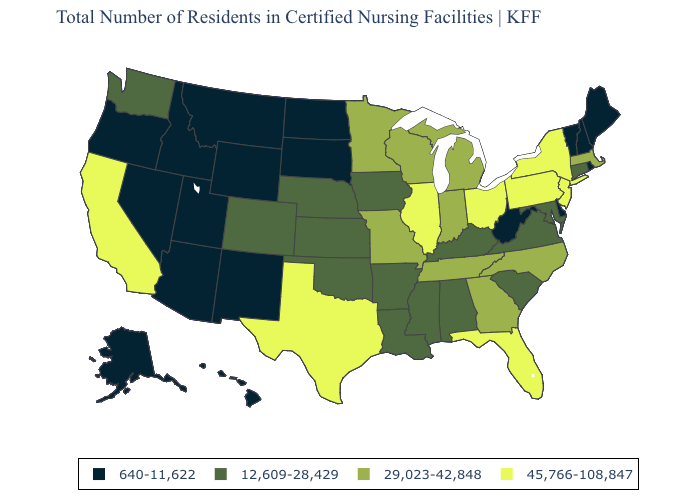What is the value of Montana?
Give a very brief answer. 640-11,622. Which states have the lowest value in the USA?
Quick response, please. Alaska, Arizona, Delaware, Hawaii, Idaho, Maine, Montana, Nevada, New Hampshire, New Mexico, North Dakota, Oregon, Rhode Island, South Dakota, Utah, Vermont, West Virginia, Wyoming. Name the states that have a value in the range 640-11,622?
Write a very short answer. Alaska, Arizona, Delaware, Hawaii, Idaho, Maine, Montana, Nevada, New Hampshire, New Mexico, North Dakota, Oregon, Rhode Island, South Dakota, Utah, Vermont, West Virginia, Wyoming. Which states have the lowest value in the USA?
Write a very short answer. Alaska, Arizona, Delaware, Hawaii, Idaho, Maine, Montana, Nevada, New Hampshire, New Mexico, North Dakota, Oregon, Rhode Island, South Dakota, Utah, Vermont, West Virginia, Wyoming. Does Virginia have the lowest value in the USA?
Keep it brief. No. Name the states that have a value in the range 12,609-28,429?
Give a very brief answer. Alabama, Arkansas, Colorado, Connecticut, Iowa, Kansas, Kentucky, Louisiana, Maryland, Mississippi, Nebraska, Oklahoma, South Carolina, Virginia, Washington. Which states hav the highest value in the West?
Short answer required. California. Does Indiana have the same value as Missouri?
Concise answer only. Yes. What is the value of North Carolina?
Write a very short answer. 29,023-42,848. What is the value of Florida?
Give a very brief answer. 45,766-108,847. What is the value of Arizona?
Short answer required. 640-11,622. Does Alabama have the same value as Nebraska?
Be succinct. Yes. Name the states that have a value in the range 640-11,622?
Concise answer only. Alaska, Arizona, Delaware, Hawaii, Idaho, Maine, Montana, Nevada, New Hampshire, New Mexico, North Dakota, Oregon, Rhode Island, South Dakota, Utah, Vermont, West Virginia, Wyoming. Name the states that have a value in the range 29,023-42,848?
Answer briefly. Georgia, Indiana, Massachusetts, Michigan, Minnesota, Missouri, North Carolina, Tennessee, Wisconsin. Among the states that border West Virginia , does Pennsylvania have the lowest value?
Quick response, please. No. 